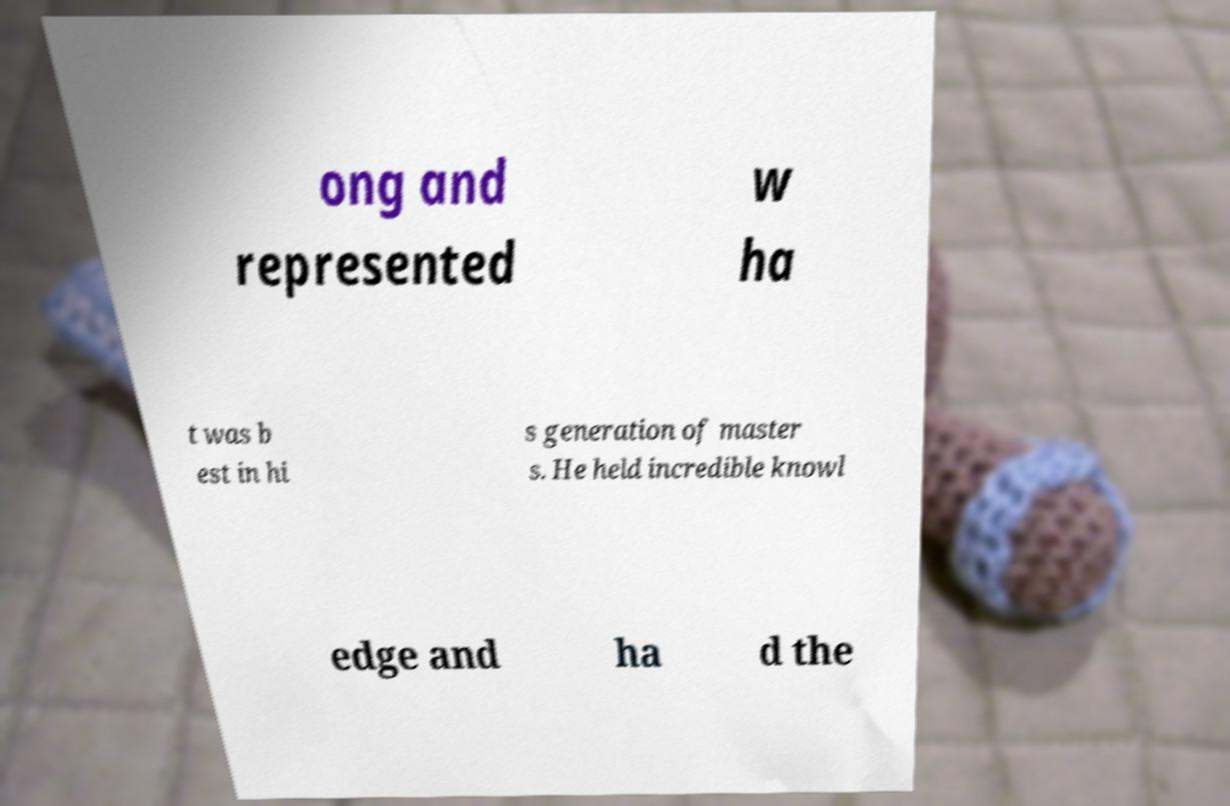Could you assist in decoding the text presented in this image and type it out clearly? ong and represented w ha t was b est in hi s generation of master s. He held incredible knowl edge and ha d the 